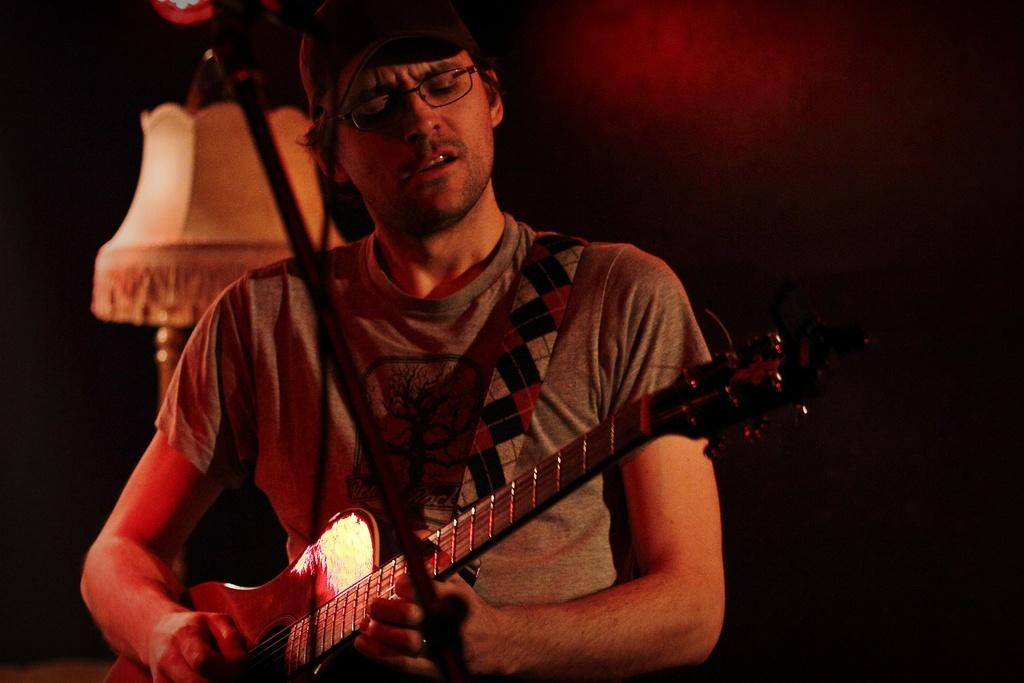What is the man in the picture doing? The man is playing the guitar. What is the man wearing on his upper body? The man is wearing a t-shirt. What accessory is the man wearing on his face? The man is wearing spectacles. What type of toothbrush is the man using while playing the guitar? There is no toothbrush present in the image, and the man is not using one while playing the guitar. 